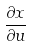<formula> <loc_0><loc_0><loc_500><loc_500>\frac { \partial x } { \partial u }</formula> 